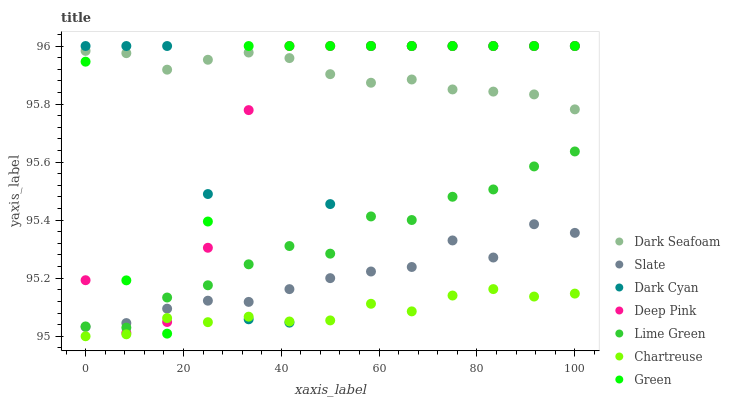Does Chartreuse have the minimum area under the curve?
Answer yes or no. Yes. Does Dark Seafoam have the maximum area under the curve?
Answer yes or no. Yes. Does Slate have the minimum area under the curve?
Answer yes or no. No. Does Slate have the maximum area under the curve?
Answer yes or no. No. Is Dark Seafoam the smoothest?
Answer yes or no. Yes. Is Dark Cyan the roughest?
Answer yes or no. Yes. Is Slate the smoothest?
Answer yes or no. No. Is Slate the roughest?
Answer yes or no. No. Does Chartreuse have the lowest value?
Answer yes or no. Yes. Does Slate have the lowest value?
Answer yes or no. No. Does Dark Cyan have the highest value?
Answer yes or no. Yes. Does Slate have the highest value?
Answer yes or no. No. Is Slate less than Dark Seafoam?
Answer yes or no. Yes. Is Dark Seafoam greater than Lime Green?
Answer yes or no. Yes. Does Chartreuse intersect Green?
Answer yes or no. Yes. Is Chartreuse less than Green?
Answer yes or no. No. Is Chartreuse greater than Green?
Answer yes or no. No. Does Slate intersect Dark Seafoam?
Answer yes or no. No. 